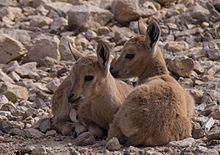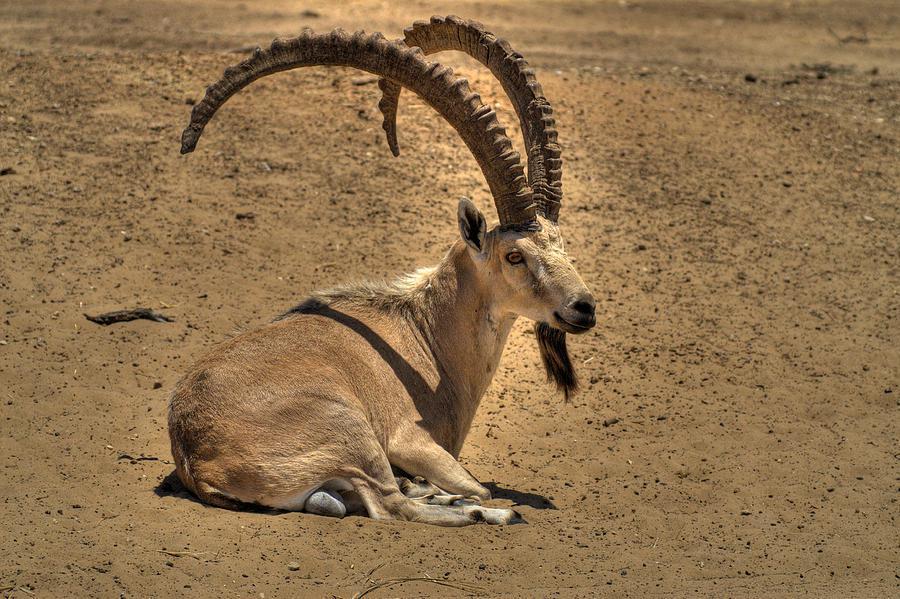The first image is the image on the left, the second image is the image on the right. Given the left and right images, does the statement "One of the paired images features exactly two animals." hold true? Answer yes or no. Yes. 